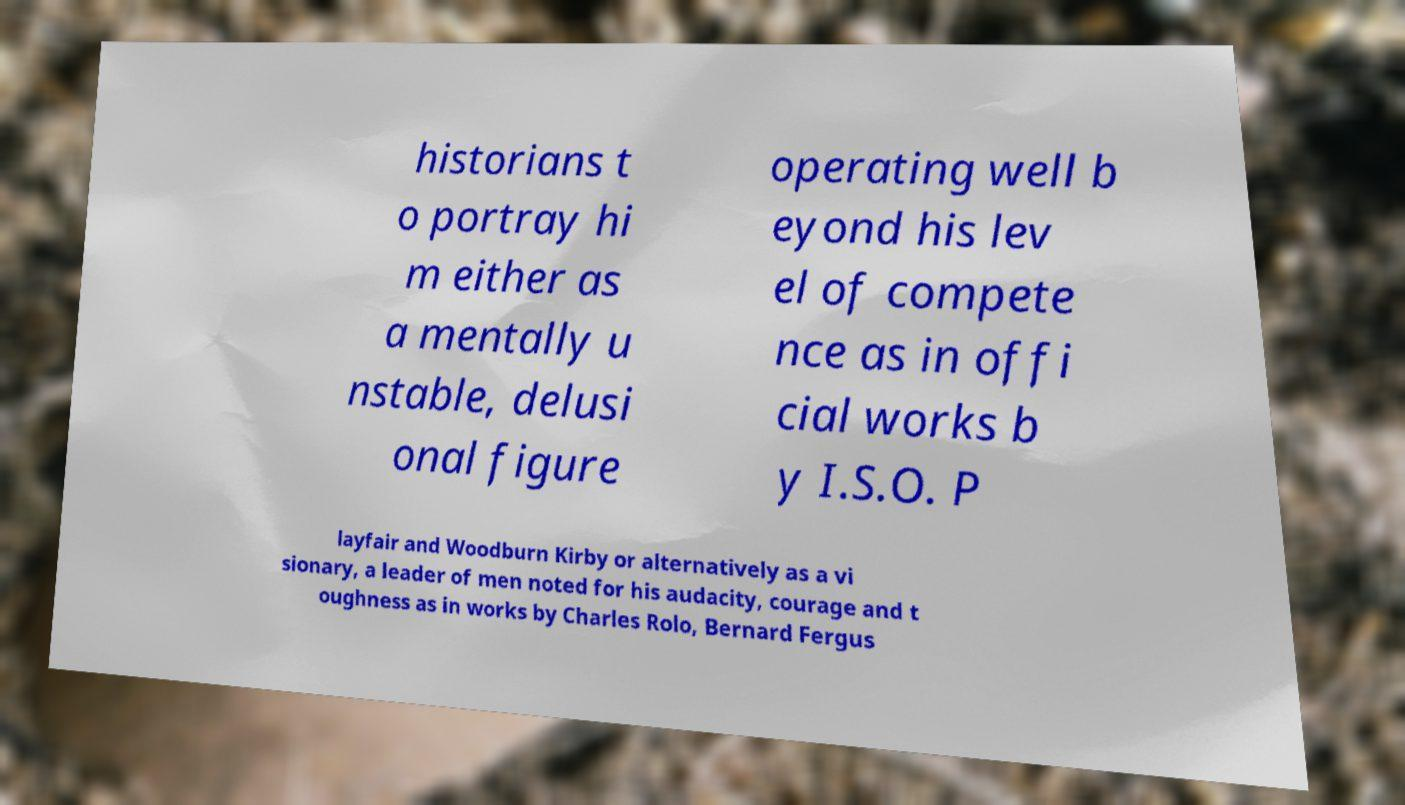For documentation purposes, I need the text within this image transcribed. Could you provide that? historians t o portray hi m either as a mentally u nstable, delusi onal figure operating well b eyond his lev el of compete nce as in offi cial works b y I.S.O. P layfair and Woodburn Kirby or alternatively as a vi sionary, a leader of men noted for his audacity, courage and t oughness as in works by Charles Rolo, Bernard Fergus 